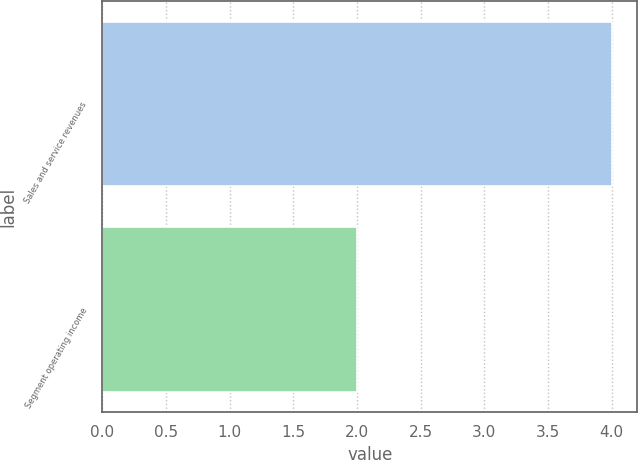<chart> <loc_0><loc_0><loc_500><loc_500><bar_chart><fcel>Sales and service revenues<fcel>Segment operating income<nl><fcel>4<fcel>2<nl></chart> 